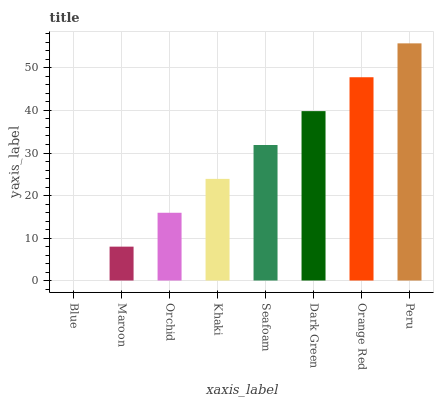Is Blue the minimum?
Answer yes or no. Yes. Is Peru the maximum?
Answer yes or no. Yes. Is Maroon the minimum?
Answer yes or no. No. Is Maroon the maximum?
Answer yes or no. No. Is Maroon greater than Blue?
Answer yes or no. Yes. Is Blue less than Maroon?
Answer yes or no. Yes. Is Blue greater than Maroon?
Answer yes or no. No. Is Maroon less than Blue?
Answer yes or no. No. Is Seafoam the high median?
Answer yes or no. Yes. Is Khaki the low median?
Answer yes or no. Yes. Is Khaki the high median?
Answer yes or no. No. Is Peru the low median?
Answer yes or no. No. 